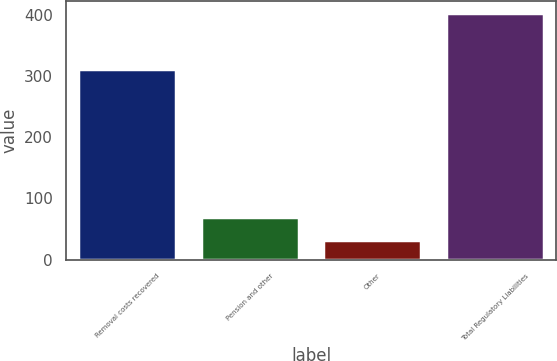Convert chart to OTSL. <chart><loc_0><loc_0><loc_500><loc_500><bar_chart><fcel>Removal costs recovered<fcel>Pension and other<fcel>Other<fcel>Total Regulatory Liabilities<nl><fcel>311<fcel>69<fcel>32<fcel>402<nl></chart> 